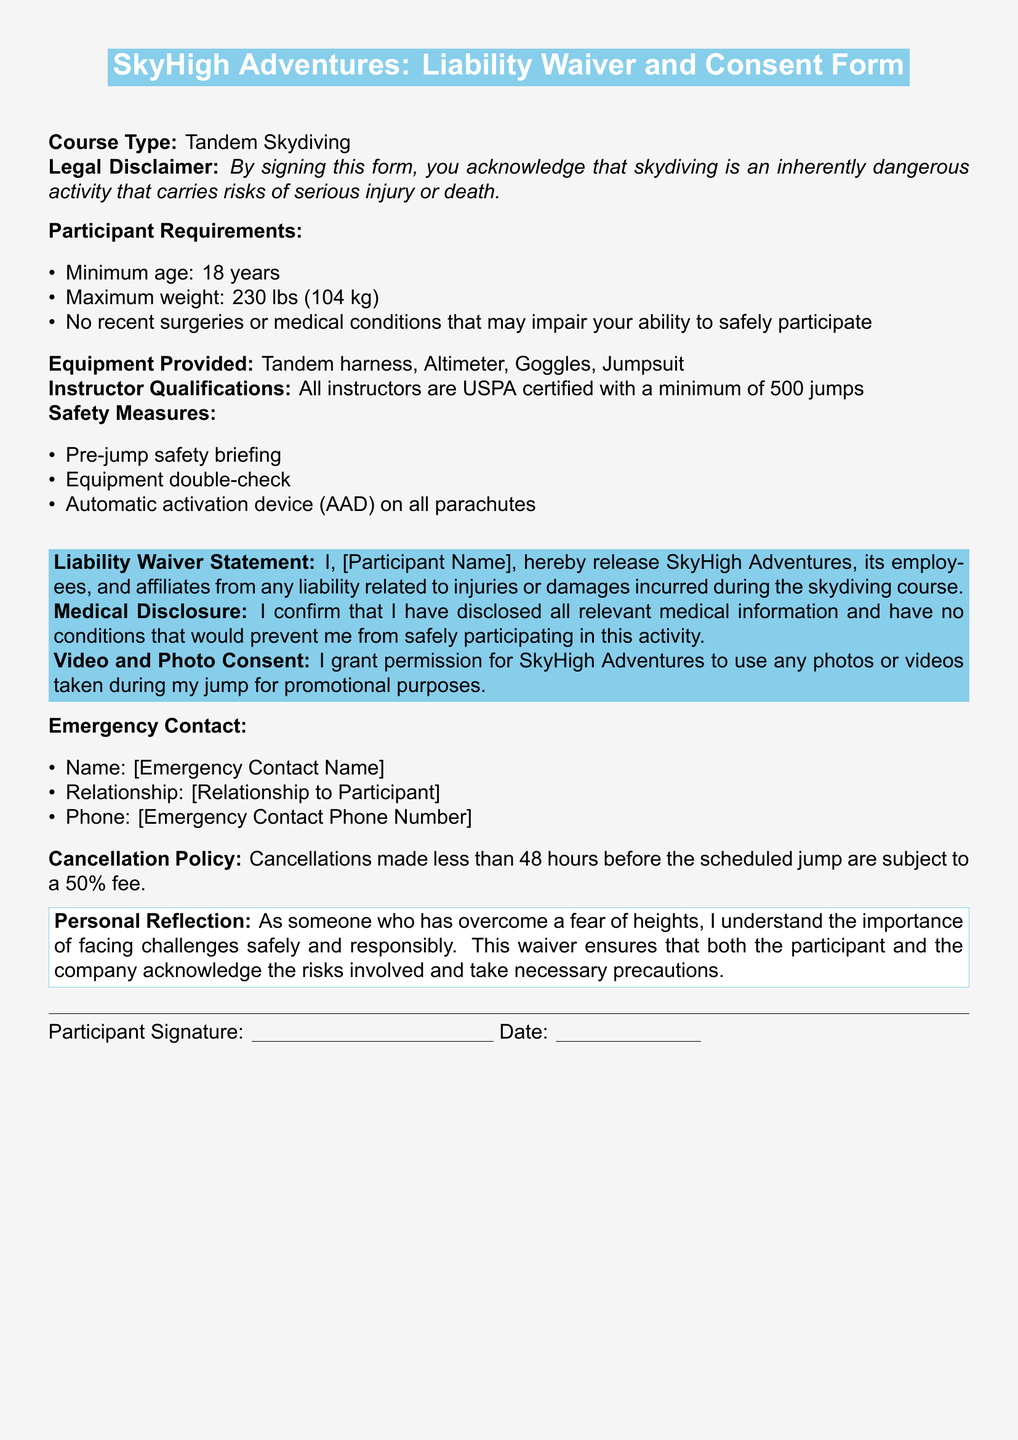what is the minimum age for participants? The document states that the minimum age requirement for participants is clearly outlined under Participant Requirements.
Answer: 18 years what is the maximum weight allowed for the skydiving course? The maximum weight is specified in the Participant Requirements section, indicating a clear cutoff for safety.
Answer: 230 lbs who certifies the instructors? The document mentions the certification body responsible for the instructors' qualifications, ensuring they meet industry standards.
Answer: USPA what happens if you cancel less than 48 hours before the jump? The Cancellation Policy specifies the consequences of a last-minute cancellation, indicating the financial implications for participants.
Answer: 50% fee what equipment is provided for participants? The document provides a list of equipment included in the skydiving course, essential for participant safety and functionality.
Answer: Tandem harness, Altimeter, Goggles, Jumpsuit what is required from participants regarding medical conditions? The Liability Waiver and Medical Disclosure section requests specific actions from participants to ensure they are fit to skydive.
Answer: Disclosure of medical information how many jumps must instructors have completed? The document sets a minimum requirement for instructor experience, establishing their competency in managing safety.
Answer: 500 jumps what is included in the safety measures? The document lists essential precautions taken to enhance safety for participants, emphasizing the company’s commitment.
Answer: Pre-jump safety briefing, Equipment double-check, AAD on all parachutes who can consent to the use of photos or videos taken during the jump? The Video and Photo Consent part of the waiver specifies who grants this permission, relating to the document's legal framework.
Answer: Participant 